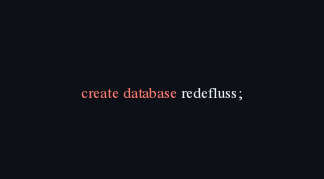Convert code to text. <code><loc_0><loc_0><loc_500><loc_500><_SQL_>create database redefluss;
</code> 